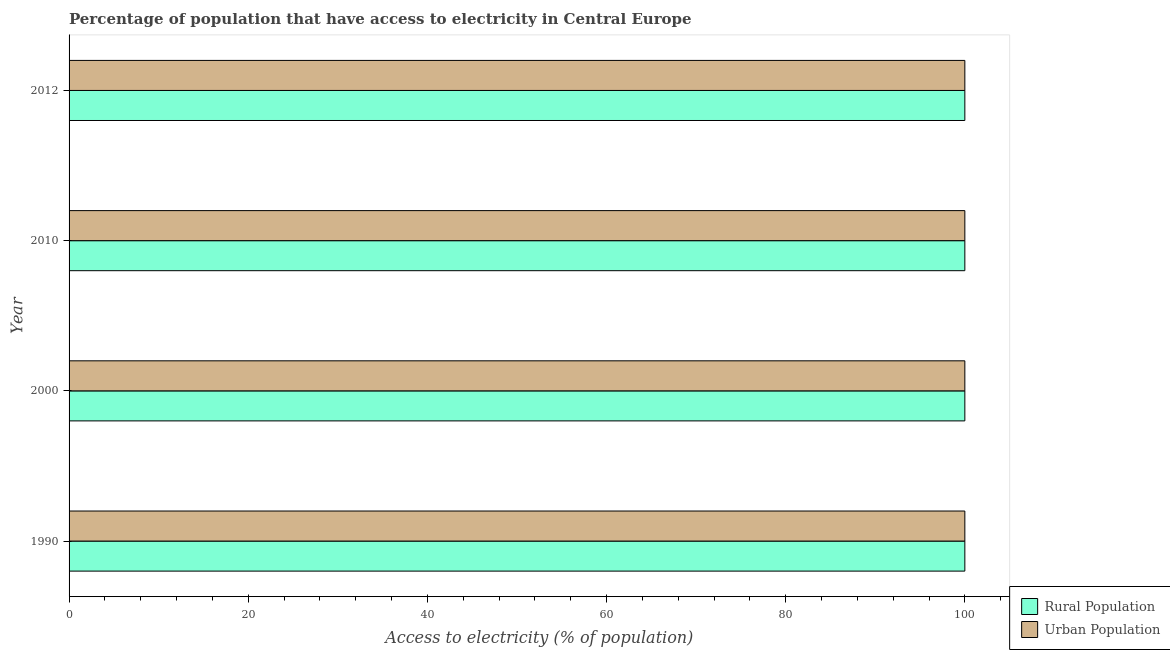How many groups of bars are there?
Provide a succinct answer. 4. Are the number of bars per tick equal to the number of legend labels?
Provide a short and direct response. Yes. Are the number of bars on each tick of the Y-axis equal?
Offer a terse response. Yes. How many bars are there on the 4th tick from the top?
Your answer should be very brief. 2. In how many cases, is the number of bars for a given year not equal to the number of legend labels?
Your response must be concise. 0. What is the percentage of urban population having access to electricity in 2012?
Keep it short and to the point. 100. Across all years, what is the maximum percentage of urban population having access to electricity?
Offer a terse response. 100. Across all years, what is the minimum percentage of rural population having access to electricity?
Make the answer very short. 100. In which year was the percentage of urban population having access to electricity maximum?
Give a very brief answer. 1990. In which year was the percentage of rural population having access to electricity minimum?
Keep it short and to the point. 1990. What is the total percentage of urban population having access to electricity in the graph?
Your answer should be very brief. 400. What is the difference between the percentage of urban population having access to electricity in 2000 and the percentage of rural population having access to electricity in 2012?
Provide a succinct answer. 0. What is the average percentage of urban population having access to electricity per year?
Your answer should be compact. 100. In how many years, is the percentage of rural population having access to electricity greater than 16 %?
Your answer should be compact. 4. What is the difference between the highest and the second highest percentage of urban population having access to electricity?
Your answer should be very brief. 0. What does the 2nd bar from the top in 1990 represents?
Your answer should be very brief. Rural Population. What does the 2nd bar from the bottom in 1990 represents?
Offer a very short reply. Urban Population. How many bars are there?
Offer a terse response. 8. How many years are there in the graph?
Your response must be concise. 4. Are the values on the major ticks of X-axis written in scientific E-notation?
Your response must be concise. No. Does the graph contain any zero values?
Your response must be concise. No. Does the graph contain grids?
Provide a succinct answer. No. Where does the legend appear in the graph?
Provide a short and direct response. Bottom right. How many legend labels are there?
Provide a succinct answer. 2. How are the legend labels stacked?
Your answer should be very brief. Vertical. What is the title of the graph?
Keep it short and to the point. Percentage of population that have access to electricity in Central Europe. Does "Researchers" appear as one of the legend labels in the graph?
Offer a terse response. No. What is the label or title of the X-axis?
Your answer should be compact. Access to electricity (% of population). What is the Access to electricity (% of population) in Rural Population in 1990?
Ensure brevity in your answer.  100. What is the Access to electricity (% of population) in Rural Population in 2000?
Offer a very short reply. 100. What is the Access to electricity (% of population) of Urban Population in 2000?
Provide a short and direct response. 100. What is the Access to electricity (% of population) of Urban Population in 2010?
Provide a succinct answer. 100. What is the Access to electricity (% of population) of Urban Population in 2012?
Provide a succinct answer. 100. Across all years, what is the maximum Access to electricity (% of population) of Urban Population?
Make the answer very short. 100. Across all years, what is the minimum Access to electricity (% of population) in Rural Population?
Ensure brevity in your answer.  100. What is the total Access to electricity (% of population) of Urban Population in the graph?
Offer a terse response. 400. What is the difference between the Access to electricity (% of population) of Urban Population in 1990 and that in 2000?
Your answer should be very brief. 0. What is the difference between the Access to electricity (% of population) in Urban Population in 1990 and that in 2010?
Offer a very short reply. 0. What is the difference between the Access to electricity (% of population) in Urban Population in 1990 and that in 2012?
Provide a short and direct response. 0. What is the difference between the Access to electricity (% of population) in Rural Population in 2000 and that in 2012?
Your answer should be compact. 0. What is the difference between the Access to electricity (% of population) of Urban Population in 2000 and that in 2012?
Provide a short and direct response. 0. What is the difference between the Access to electricity (% of population) in Urban Population in 2010 and that in 2012?
Your answer should be very brief. 0. What is the difference between the Access to electricity (% of population) in Rural Population in 2000 and the Access to electricity (% of population) in Urban Population in 2010?
Provide a succinct answer. 0. What is the difference between the Access to electricity (% of population) of Rural Population in 2010 and the Access to electricity (% of population) of Urban Population in 2012?
Give a very brief answer. 0. What is the average Access to electricity (% of population) of Rural Population per year?
Keep it short and to the point. 100. What is the average Access to electricity (% of population) in Urban Population per year?
Provide a short and direct response. 100. In the year 1990, what is the difference between the Access to electricity (% of population) in Rural Population and Access to electricity (% of population) in Urban Population?
Make the answer very short. 0. What is the ratio of the Access to electricity (% of population) of Rural Population in 1990 to that in 2000?
Offer a terse response. 1. What is the ratio of the Access to electricity (% of population) of Urban Population in 1990 to that in 2000?
Provide a succinct answer. 1. What is the ratio of the Access to electricity (% of population) of Urban Population in 1990 to that in 2010?
Provide a short and direct response. 1. What is the ratio of the Access to electricity (% of population) in Rural Population in 1990 to that in 2012?
Offer a terse response. 1. What is the ratio of the Access to electricity (% of population) in Rural Population in 2000 to that in 2012?
Offer a very short reply. 1. What is the ratio of the Access to electricity (% of population) of Urban Population in 2000 to that in 2012?
Make the answer very short. 1. What is the ratio of the Access to electricity (% of population) of Rural Population in 2010 to that in 2012?
Keep it short and to the point. 1. What is the difference between the highest and the lowest Access to electricity (% of population) in Rural Population?
Provide a succinct answer. 0. What is the difference between the highest and the lowest Access to electricity (% of population) of Urban Population?
Offer a very short reply. 0. 